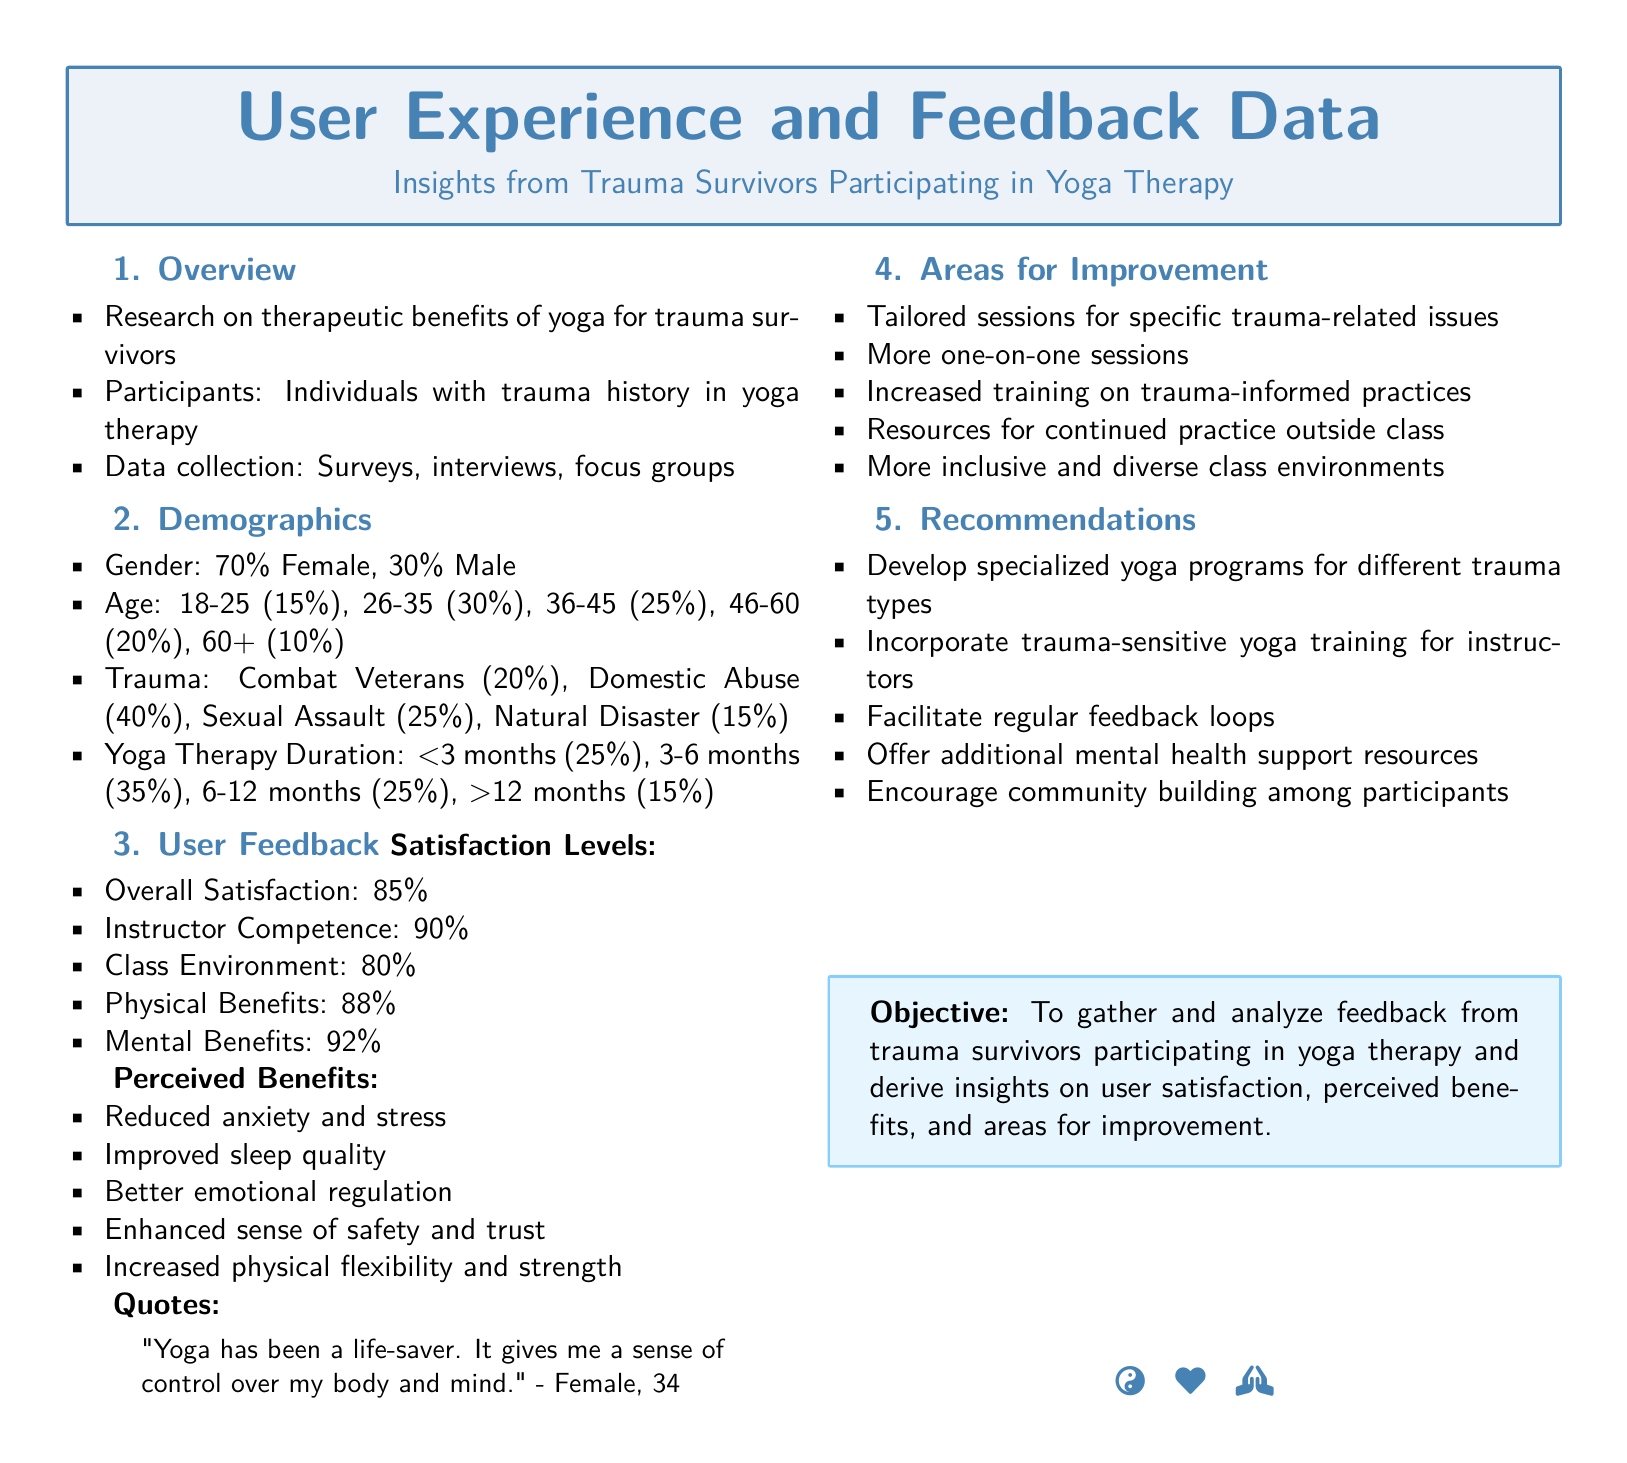what percentage of participants are female? The document states that 70% of the participants are female.
Answer: 70% what is the age range of the majority of participants? The document shows that the largest age group is 26-35 years, making it the majority.
Answer: 26-35 how many participants reported improved sleep quality? This information is part of the feedback on perceived benefits, which includes improved sleep quality but does not provide a specific number; it's inferred from overall positive responses.
Answer: Not specified what is the overall satisfaction level of participants? The document lists overall satisfaction as a specific percentage.
Answer: 85% what recommendation is made regarding instructor training? The document suggests incorporating trauma-sensitive yoga training for instructors.
Answer: Trauma-sensitive yoga training how long did 25% of participants engage in yoga therapy? The document specifies that 25% of participants engaged in yoga therapy for less than 3 months.
Answer: <3 months which trauma category had the highest percentage of participants? According to the demographics section, domestic abuse had the highest percentage of trauma survivors.
Answer: Domestic Abuse what is the perceived benefit concerning emotional regulation? The document lists better emotional regulation as one of the perceived benefits from yoga therapy.
Answer: Better emotional regulation 